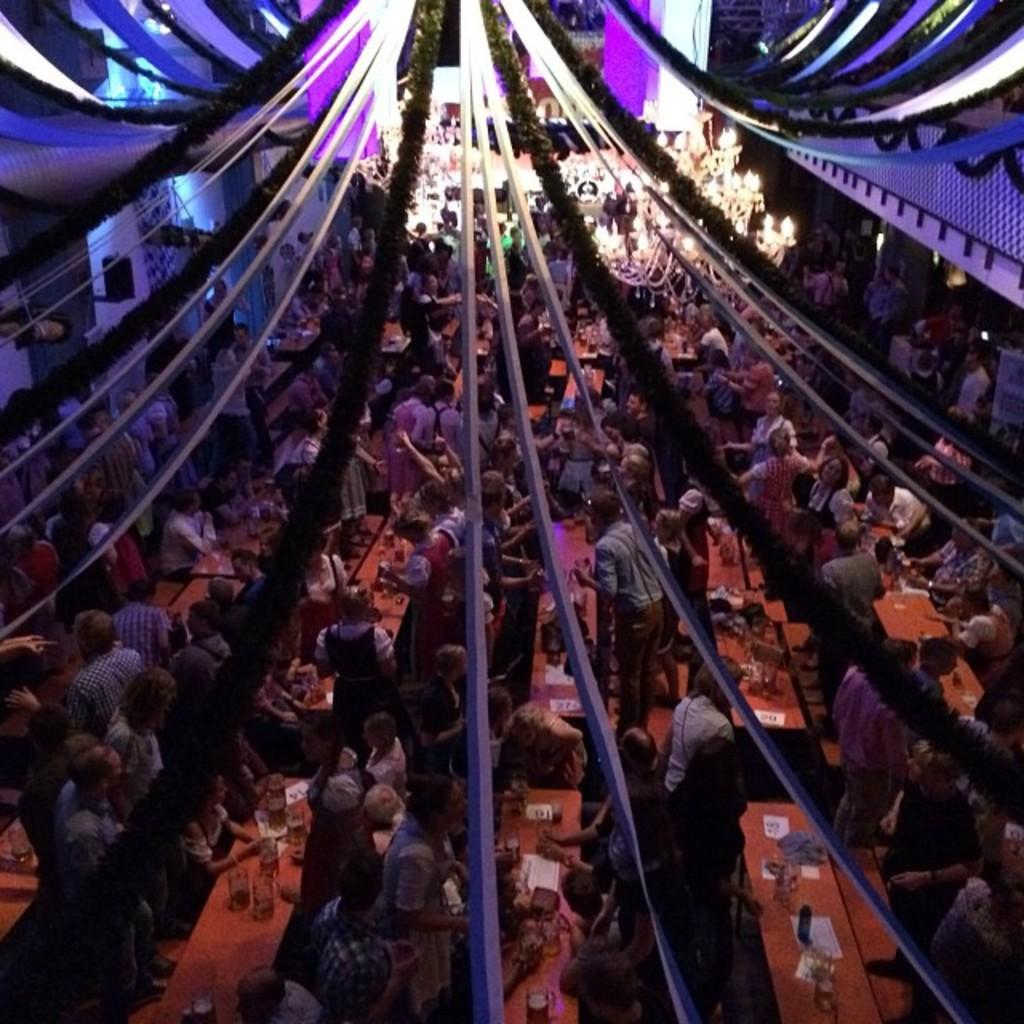How many people are in the image? There are many people in the image. What can be seen near the people in the image? The people are near a table. What type of items are visible at the top of the image? There are decorative items visible at the top of the image. What is the health condition of the owner of the decorative items in the image? There is no information about the health condition of the owner of the decorative items, as the image does not mention an owner. 